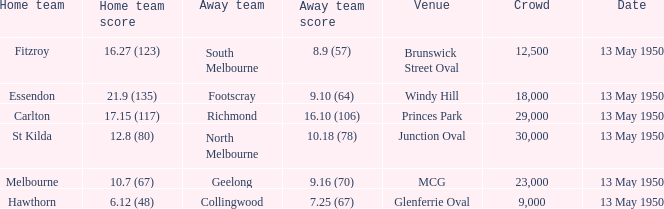Who was the away team that played Fitzroy on May 13, 1950 at Brunswick Street Oval. South Melbourne. 